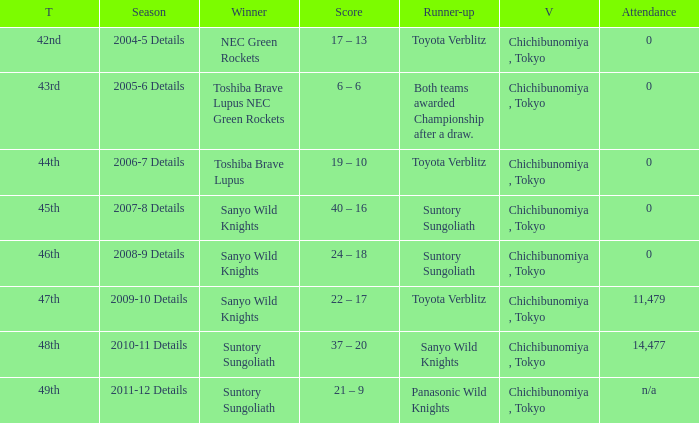What is the Score when the winner was sanyo wild knights, and a Runner-up of suntory sungoliath? 40 – 16, 24 – 18. Could you parse the entire table as a dict? {'header': ['T', 'Season', 'Winner', 'Score', 'Runner-up', 'V', 'Attendance'], 'rows': [['42nd', '2004-5 Details', 'NEC Green Rockets', '17 – 13', 'Toyota Verblitz', 'Chichibunomiya , Tokyo', '0'], ['43rd', '2005-6 Details', 'Toshiba Brave Lupus NEC Green Rockets', '6 – 6', 'Both teams awarded Championship after a draw.', 'Chichibunomiya , Tokyo', '0'], ['44th', '2006-7 Details', 'Toshiba Brave Lupus', '19 – 10', 'Toyota Verblitz', 'Chichibunomiya , Tokyo', '0'], ['45th', '2007-8 Details', 'Sanyo Wild Knights', '40 – 16', 'Suntory Sungoliath', 'Chichibunomiya , Tokyo', '0'], ['46th', '2008-9 Details', 'Sanyo Wild Knights', '24 – 18', 'Suntory Sungoliath', 'Chichibunomiya , Tokyo', '0'], ['47th', '2009-10 Details', 'Sanyo Wild Knights', '22 – 17', 'Toyota Verblitz', 'Chichibunomiya , Tokyo', '11,479'], ['48th', '2010-11 Details', 'Suntory Sungoliath', '37 – 20', 'Sanyo Wild Knights', 'Chichibunomiya , Tokyo', '14,477'], ['49th', '2011-12 Details', 'Suntory Sungoliath', '21 – 9', 'Panasonic Wild Knights', 'Chichibunomiya , Tokyo', 'n/a']]} 